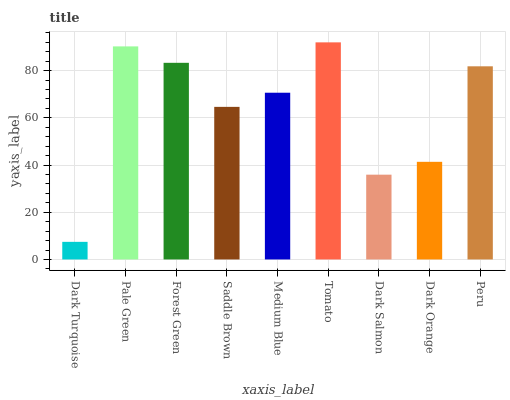Is Dark Turquoise the minimum?
Answer yes or no. Yes. Is Tomato the maximum?
Answer yes or no. Yes. Is Pale Green the minimum?
Answer yes or no. No. Is Pale Green the maximum?
Answer yes or no. No. Is Pale Green greater than Dark Turquoise?
Answer yes or no. Yes. Is Dark Turquoise less than Pale Green?
Answer yes or no. Yes. Is Dark Turquoise greater than Pale Green?
Answer yes or no. No. Is Pale Green less than Dark Turquoise?
Answer yes or no. No. Is Medium Blue the high median?
Answer yes or no. Yes. Is Medium Blue the low median?
Answer yes or no. Yes. Is Dark Salmon the high median?
Answer yes or no. No. Is Forest Green the low median?
Answer yes or no. No. 